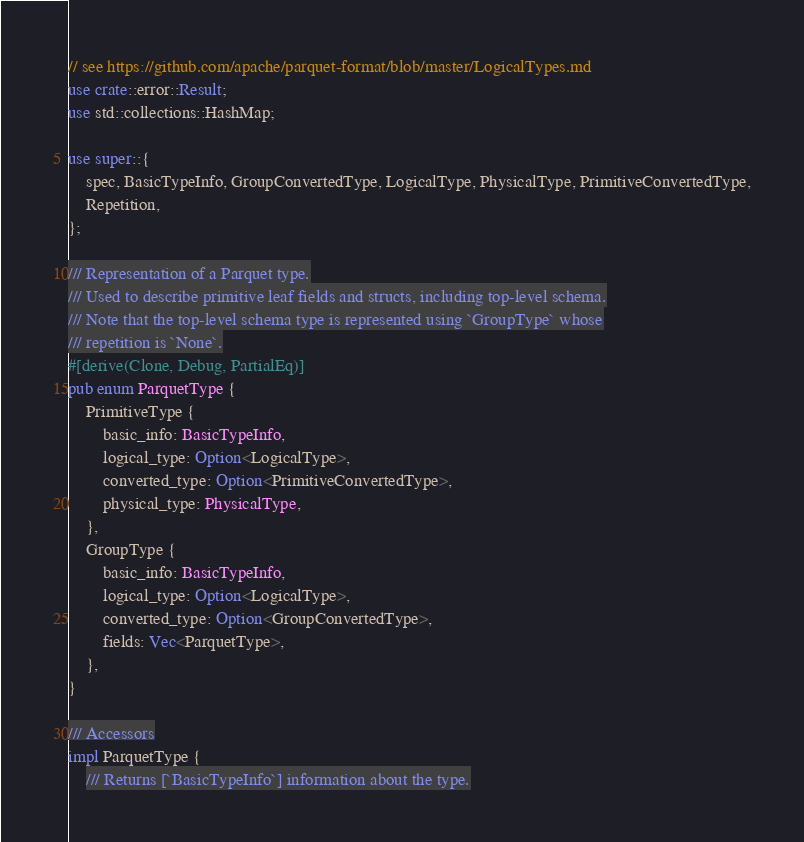<code> <loc_0><loc_0><loc_500><loc_500><_Rust_>// see https://github.com/apache/parquet-format/blob/master/LogicalTypes.md
use crate::error::Result;
use std::collections::HashMap;

use super::{
    spec, BasicTypeInfo, GroupConvertedType, LogicalType, PhysicalType, PrimitiveConvertedType,
    Repetition,
};

/// Representation of a Parquet type.
/// Used to describe primitive leaf fields and structs, including top-level schema.
/// Note that the top-level schema type is represented using `GroupType` whose
/// repetition is `None`.
#[derive(Clone, Debug, PartialEq)]
pub enum ParquetType {
    PrimitiveType {
        basic_info: BasicTypeInfo,
        logical_type: Option<LogicalType>,
        converted_type: Option<PrimitiveConvertedType>,
        physical_type: PhysicalType,
    },
    GroupType {
        basic_info: BasicTypeInfo,
        logical_type: Option<LogicalType>,
        converted_type: Option<GroupConvertedType>,
        fields: Vec<ParquetType>,
    },
}

/// Accessors
impl ParquetType {
    /// Returns [`BasicTypeInfo`] information about the type.</code> 